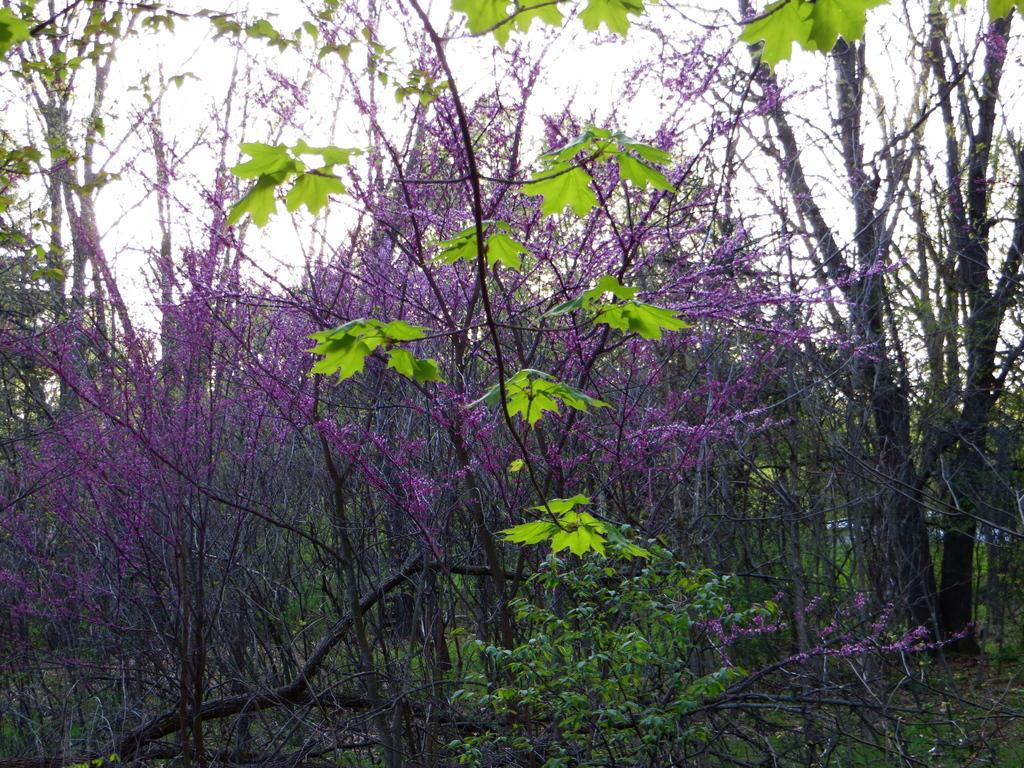What type of vegetation can be seen in the image? There are trees in the image. What else can be seen on the ground in the image? There is grass in the image. What is visible at the top of the image? The sky is visible at the top of the image. What type of cloth can be seen hanging from the trees in the image? There is no cloth hanging from the trees in the image; only trees, grass, and the sky are present. What day of the week is depicted in the image? The image does not depict a specific day of the week; it only shows trees, grass, and the sky. 